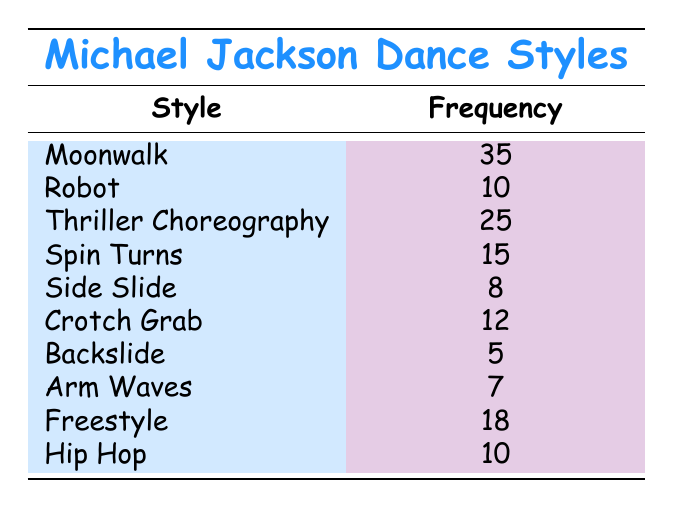What is the frequency of the Moonwalk dance style? The table lists the frequency for each dance style. The frequency for the Moonwalk is specifically mentioned, which shows it has a value of 35.
Answer: 35 How many dance styles have a frequency of 10 or more? The dance styles with a frequency of 10 or more are Moonwalk (35), Thriller Choreography (25), Spin Turns (15), Crotch Grab (12), Freestyle (18), Robot (10), and Hip Hop (10). Counting these styles gives us a total of 7.
Answer: 7 What is the total frequency of all dance styles listed? To find the total frequency, we add all the frequencies together: 35 (Moonwalk) + 10 (Robot) + 25 (Thriller Choreography) + 15 (Spin Turns) + 8 (Side Slide) + 12 (Crotch Grab) + 5 (Backslide) + 7 (Arm Waves) + 18 (Freestyle) + 10 (Hip Hop) =  35 + 10 + 25 + 15 + 8 + 12 + 5 + 7 + 18 + 10 = 235.
Answer: 235 Which dance style has the lowest frequency, and what is that frequency? Looking through the frequencies listed for each dance style, Backslide has the lowest frequency at 5.
Answer: Backslide, 5 Is the frequency of the Thriller Choreography greater than that of the Robot? The frequency for Thriller Choreography is 25 and for Robot, it is 10. Since 25 is greater than 10, the answer is yes.
Answer: Yes What is the average frequency of the dance styles that are performed less frequently than the Crotch Grab? The dance styles with frequencies less than Crotch Grab (12) are Backslide (5), Arm Waves (7), and Side Slide (8). To find the average, we first sum these frequencies: 5 + 7 + 8 = 20. There are 3 styles, so we divide the total by the number of styles: 20 / 3 = approximately 6.67.
Answer: 6.67 Which dance style is performed more frequently: Spin Turns or Freestyle? The frequency for Spin Turns is 15, and the frequency for Freestyle is 18. Comparing these two, Freestyle has a higher frequency than Spin Turns.
Answer: Freestyle How many more times frequently is the Moonwalk performed than the Backslide? The frequency of the Moonwalk is 35, and for Backslide, it is 5. To find out how many more times, we subtract the frequency of Backslide from that of Moonwalk: 35 - 5 = 30. Thus, the Moonwalk is performed 30 more times frequently than the Backslide.
Answer: 30 Which dance styles have the same frequency of 10? Reviewing the table, both Robot and Hip Hop have a frequency of 10. Therefore, the dance styles with the same frequency are Robot and Hip Hop.
Answer: Robot, Hip Hop 